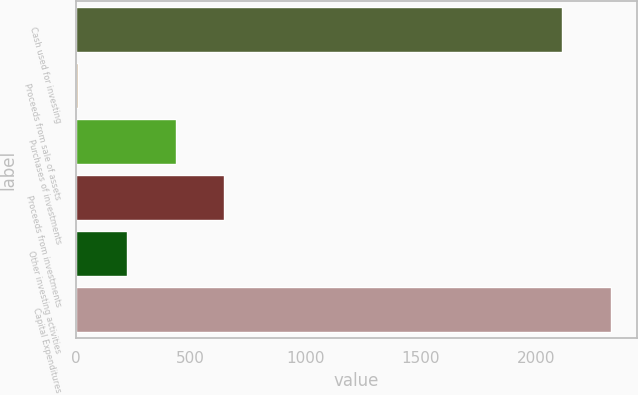Convert chart to OTSL. <chart><loc_0><loc_0><loc_500><loc_500><bar_chart><fcel>Cash used for investing<fcel>Proceeds from sale of assets<fcel>Purchases of investments<fcel>Proceeds from investments<fcel>Other investing activities<fcel>Capital Expenditures<nl><fcel>2113.4<fcel>11.1<fcel>434.6<fcel>646.35<fcel>222.85<fcel>2325.15<nl></chart> 